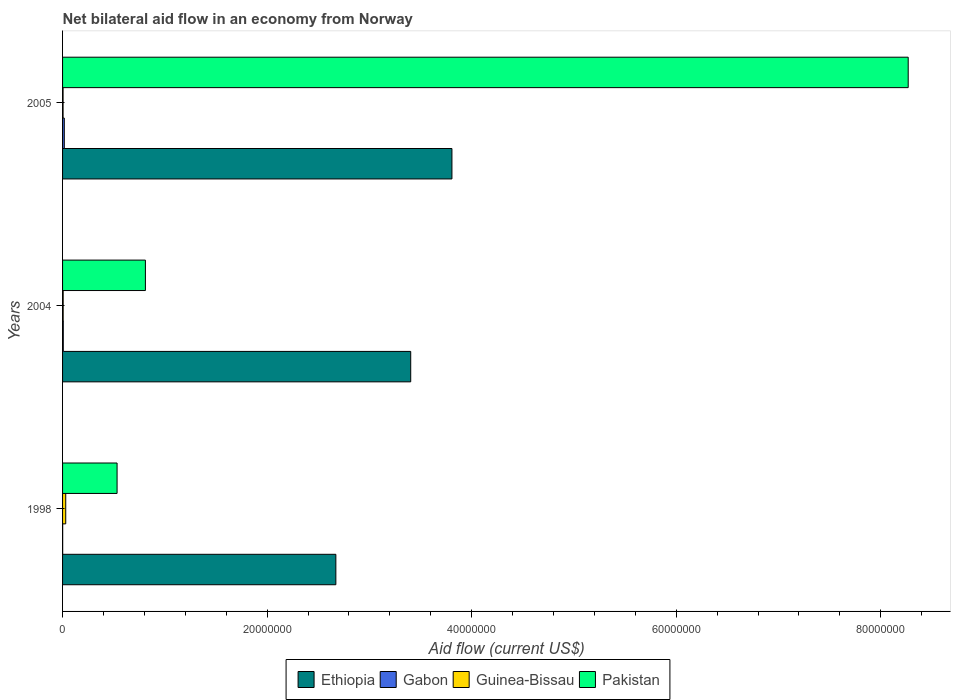How many groups of bars are there?
Make the answer very short. 3. Are the number of bars on each tick of the Y-axis equal?
Make the answer very short. Yes. How many bars are there on the 3rd tick from the bottom?
Give a very brief answer. 4. What is the net bilateral aid flow in Gabon in 2004?
Provide a succinct answer. 7.00e+04. Across all years, what is the maximum net bilateral aid flow in Guinea-Bissau?
Offer a very short reply. 3.10e+05. What is the total net bilateral aid flow in Pakistan in the graph?
Your response must be concise. 9.61e+07. What is the difference between the net bilateral aid flow in Guinea-Bissau in 1998 and that in 2004?
Your response must be concise. 2.50e+05. What is the difference between the net bilateral aid flow in Gabon in 2004 and the net bilateral aid flow in Pakistan in 1998?
Your answer should be very brief. -5.26e+06. What is the average net bilateral aid flow in Gabon per year?
Offer a terse response. 8.33e+04. In the year 2004, what is the difference between the net bilateral aid flow in Pakistan and net bilateral aid flow in Gabon?
Make the answer very short. 8.03e+06. In how many years, is the net bilateral aid flow in Pakistan greater than 52000000 US$?
Keep it short and to the point. 1. What is the ratio of the net bilateral aid flow in Gabon in 1998 to that in 2005?
Provide a succinct answer. 0.06. Is the difference between the net bilateral aid flow in Pakistan in 2004 and 2005 greater than the difference between the net bilateral aid flow in Gabon in 2004 and 2005?
Give a very brief answer. No. What is the difference between the highest and the second highest net bilateral aid flow in Ethiopia?
Provide a short and direct response. 4.03e+06. What is the difference between the highest and the lowest net bilateral aid flow in Gabon?
Keep it short and to the point. 1.60e+05. Is it the case that in every year, the sum of the net bilateral aid flow in Gabon and net bilateral aid flow in Pakistan is greater than the sum of net bilateral aid flow in Guinea-Bissau and net bilateral aid flow in Ethiopia?
Provide a succinct answer. Yes. What does the 3rd bar from the top in 2005 represents?
Ensure brevity in your answer.  Gabon. What does the 3rd bar from the bottom in 1998 represents?
Offer a very short reply. Guinea-Bissau. How many bars are there?
Offer a terse response. 12. Are all the bars in the graph horizontal?
Keep it short and to the point. Yes. How many years are there in the graph?
Your answer should be very brief. 3. What is the difference between two consecutive major ticks on the X-axis?
Your answer should be compact. 2.00e+07. Does the graph contain any zero values?
Give a very brief answer. No. Where does the legend appear in the graph?
Keep it short and to the point. Bottom center. What is the title of the graph?
Provide a succinct answer. Net bilateral aid flow in an economy from Norway. What is the label or title of the X-axis?
Offer a very short reply. Aid flow (current US$). What is the label or title of the Y-axis?
Make the answer very short. Years. What is the Aid flow (current US$) of Ethiopia in 1998?
Your answer should be very brief. 2.67e+07. What is the Aid flow (current US$) in Gabon in 1998?
Offer a terse response. 10000. What is the Aid flow (current US$) of Pakistan in 1998?
Ensure brevity in your answer.  5.33e+06. What is the Aid flow (current US$) of Ethiopia in 2004?
Provide a succinct answer. 3.40e+07. What is the Aid flow (current US$) in Pakistan in 2004?
Your answer should be very brief. 8.10e+06. What is the Aid flow (current US$) in Ethiopia in 2005?
Provide a succinct answer. 3.81e+07. What is the Aid flow (current US$) in Pakistan in 2005?
Give a very brief answer. 8.27e+07. Across all years, what is the maximum Aid flow (current US$) in Ethiopia?
Your answer should be compact. 3.81e+07. Across all years, what is the maximum Aid flow (current US$) of Gabon?
Give a very brief answer. 1.70e+05. Across all years, what is the maximum Aid flow (current US$) in Guinea-Bissau?
Provide a short and direct response. 3.10e+05. Across all years, what is the maximum Aid flow (current US$) in Pakistan?
Your answer should be compact. 8.27e+07. Across all years, what is the minimum Aid flow (current US$) of Ethiopia?
Offer a terse response. 2.67e+07. Across all years, what is the minimum Aid flow (current US$) of Gabon?
Offer a very short reply. 10000. Across all years, what is the minimum Aid flow (current US$) of Pakistan?
Provide a succinct answer. 5.33e+06. What is the total Aid flow (current US$) in Ethiopia in the graph?
Offer a terse response. 9.88e+07. What is the total Aid flow (current US$) in Gabon in the graph?
Offer a terse response. 2.50e+05. What is the total Aid flow (current US$) of Pakistan in the graph?
Your response must be concise. 9.61e+07. What is the difference between the Aid flow (current US$) of Ethiopia in 1998 and that in 2004?
Offer a terse response. -7.32e+06. What is the difference between the Aid flow (current US$) in Gabon in 1998 and that in 2004?
Offer a very short reply. -6.00e+04. What is the difference between the Aid flow (current US$) in Guinea-Bissau in 1998 and that in 2004?
Keep it short and to the point. 2.50e+05. What is the difference between the Aid flow (current US$) of Pakistan in 1998 and that in 2004?
Your answer should be compact. -2.77e+06. What is the difference between the Aid flow (current US$) in Ethiopia in 1998 and that in 2005?
Your response must be concise. -1.14e+07. What is the difference between the Aid flow (current US$) of Guinea-Bissau in 1998 and that in 2005?
Provide a short and direct response. 2.60e+05. What is the difference between the Aid flow (current US$) of Pakistan in 1998 and that in 2005?
Your answer should be compact. -7.74e+07. What is the difference between the Aid flow (current US$) in Ethiopia in 2004 and that in 2005?
Offer a very short reply. -4.03e+06. What is the difference between the Aid flow (current US$) of Pakistan in 2004 and that in 2005?
Provide a succinct answer. -7.46e+07. What is the difference between the Aid flow (current US$) of Ethiopia in 1998 and the Aid flow (current US$) of Gabon in 2004?
Ensure brevity in your answer.  2.66e+07. What is the difference between the Aid flow (current US$) in Ethiopia in 1998 and the Aid flow (current US$) in Guinea-Bissau in 2004?
Your response must be concise. 2.67e+07. What is the difference between the Aid flow (current US$) in Ethiopia in 1998 and the Aid flow (current US$) in Pakistan in 2004?
Provide a succinct answer. 1.86e+07. What is the difference between the Aid flow (current US$) of Gabon in 1998 and the Aid flow (current US$) of Guinea-Bissau in 2004?
Your response must be concise. -5.00e+04. What is the difference between the Aid flow (current US$) in Gabon in 1998 and the Aid flow (current US$) in Pakistan in 2004?
Your answer should be compact. -8.09e+06. What is the difference between the Aid flow (current US$) in Guinea-Bissau in 1998 and the Aid flow (current US$) in Pakistan in 2004?
Provide a succinct answer. -7.79e+06. What is the difference between the Aid flow (current US$) of Ethiopia in 1998 and the Aid flow (current US$) of Gabon in 2005?
Your answer should be compact. 2.66e+07. What is the difference between the Aid flow (current US$) in Ethiopia in 1998 and the Aid flow (current US$) in Guinea-Bissau in 2005?
Give a very brief answer. 2.67e+07. What is the difference between the Aid flow (current US$) of Ethiopia in 1998 and the Aid flow (current US$) of Pakistan in 2005?
Your answer should be very brief. -5.60e+07. What is the difference between the Aid flow (current US$) in Gabon in 1998 and the Aid flow (current US$) in Guinea-Bissau in 2005?
Provide a short and direct response. -4.00e+04. What is the difference between the Aid flow (current US$) in Gabon in 1998 and the Aid flow (current US$) in Pakistan in 2005?
Offer a very short reply. -8.27e+07. What is the difference between the Aid flow (current US$) in Guinea-Bissau in 1998 and the Aid flow (current US$) in Pakistan in 2005?
Keep it short and to the point. -8.24e+07. What is the difference between the Aid flow (current US$) of Ethiopia in 2004 and the Aid flow (current US$) of Gabon in 2005?
Keep it short and to the point. 3.39e+07. What is the difference between the Aid flow (current US$) of Ethiopia in 2004 and the Aid flow (current US$) of Guinea-Bissau in 2005?
Provide a succinct answer. 3.40e+07. What is the difference between the Aid flow (current US$) in Ethiopia in 2004 and the Aid flow (current US$) in Pakistan in 2005?
Your response must be concise. -4.86e+07. What is the difference between the Aid flow (current US$) of Gabon in 2004 and the Aid flow (current US$) of Guinea-Bissau in 2005?
Ensure brevity in your answer.  2.00e+04. What is the difference between the Aid flow (current US$) in Gabon in 2004 and the Aid flow (current US$) in Pakistan in 2005?
Your response must be concise. -8.26e+07. What is the difference between the Aid flow (current US$) of Guinea-Bissau in 2004 and the Aid flow (current US$) of Pakistan in 2005?
Offer a very short reply. -8.26e+07. What is the average Aid flow (current US$) of Ethiopia per year?
Provide a short and direct response. 3.29e+07. What is the average Aid flow (current US$) of Gabon per year?
Give a very brief answer. 8.33e+04. What is the average Aid flow (current US$) of Pakistan per year?
Your answer should be very brief. 3.20e+07. In the year 1998, what is the difference between the Aid flow (current US$) of Ethiopia and Aid flow (current US$) of Gabon?
Make the answer very short. 2.67e+07. In the year 1998, what is the difference between the Aid flow (current US$) in Ethiopia and Aid flow (current US$) in Guinea-Bissau?
Offer a terse response. 2.64e+07. In the year 1998, what is the difference between the Aid flow (current US$) of Ethiopia and Aid flow (current US$) of Pakistan?
Provide a short and direct response. 2.14e+07. In the year 1998, what is the difference between the Aid flow (current US$) in Gabon and Aid flow (current US$) in Guinea-Bissau?
Provide a short and direct response. -3.00e+05. In the year 1998, what is the difference between the Aid flow (current US$) of Gabon and Aid flow (current US$) of Pakistan?
Your answer should be compact. -5.32e+06. In the year 1998, what is the difference between the Aid flow (current US$) in Guinea-Bissau and Aid flow (current US$) in Pakistan?
Your answer should be compact. -5.02e+06. In the year 2004, what is the difference between the Aid flow (current US$) in Ethiopia and Aid flow (current US$) in Gabon?
Your response must be concise. 3.40e+07. In the year 2004, what is the difference between the Aid flow (current US$) in Ethiopia and Aid flow (current US$) in Guinea-Bissau?
Keep it short and to the point. 3.40e+07. In the year 2004, what is the difference between the Aid flow (current US$) in Ethiopia and Aid flow (current US$) in Pakistan?
Make the answer very short. 2.59e+07. In the year 2004, what is the difference between the Aid flow (current US$) in Gabon and Aid flow (current US$) in Guinea-Bissau?
Your response must be concise. 10000. In the year 2004, what is the difference between the Aid flow (current US$) in Gabon and Aid flow (current US$) in Pakistan?
Your answer should be compact. -8.03e+06. In the year 2004, what is the difference between the Aid flow (current US$) in Guinea-Bissau and Aid flow (current US$) in Pakistan?
Make the answer very short. -8.04e+06. In the year 2005, what is the difference between the Aid flow (current US$) in Ethiopia and Aid flow (current US$) in Gabon?
Offer a terse response. 3.79e+07. In the year 2005, what is the difference between the Aid flow (current US$) of Ethiopia and Aid flow (current US$) of Guinea-Bissau?
Provide a short and direct response. 3.80e+07. In the year 2005, what is the difference between the Aid flow (current US$) in Ethiopia and Aid flow (current US$) in Pakistan?
Make the answer very short. -4.46e+07. In the year 2005, what is the difference between the Aid flow (current US$) of Gabon and Aid flow (current US$) of Guinea-Bissau?
Provide a succinct answer. 1.20e+05. In the year 2005, what is the difference between the Aid flow (current US$) in Gabon and Aid flow (current US$) in Pakistan?
Make the answer very short. -8.25e+07. In the year 2005, what is the difference between the Aid flow (current US$) of Guinea-Bissau and Aid flow (current US$) of Pakistan?
Make the answer very short. -8.26e+07. What is the ratio of the Aid flow (current US$) of Ethiopia in 1998 to that in 2004?
Your answer should be very brief. 0.79. What is the ratio of the Aid flow (current US$) of Gabon in 1998 to that in 2004?
Give a very brief answer. 0.14. What is the ratio of the Aid flow (current US$) of Guinea-Bissau in 1998 to that in 2004?
Provide a succinct answer. 5.17. What is the ratio of the Aid flow (current US$) of Pakistan in 1998 to that in 2004?
Keep it short and to the point. 0.66. What is the ratio of the Aid flow (current US$) of Ethiopia in 1998 to that in 2005?
Provide a short and direct response. 0.7. What is the ratio of the Aid flow (current US$) in Gabon in 1998 to that in 2005?
Provide a succinct answer. 0.06. What is the ratio of the Aid flow (current US$) in Guinea-Bissau in 1998 to that in 2005?
Your response must be concise. 6.2. What is the ratio of the Aid flow (current US$) of Pakistan in 1998 to that in 2005?
Provide a short and direct response. 0.06. What is the ratio of the Aid flow (current US$) of Ethiopia in 2004 to that in 2005?
Ensure brevity in your answer.  0.89. What is the ratio of the Aid flow (current US$) in Gabon in 2004 to that in 2005?
Ensure brevity in your answer.  0.41. What is the ratio of the Aid flow (current US$) in Pakistan in 2004 to that in 2005?
Offer a very short reply. 0.1. What is the difference between the highest and the second highest Aid flow (current US$) of Ethiopia?
Your answer should be compact. 4.03e+06. What is the difference between the highest and the second highest Aid flow (current US$) in Pakistan?
Provide a short and direct response. 7.46e+07. What is the difference between the highest and the lowest Aid flow (current US$) in Ethiopia?
Provide a succinct answer. 1.14e+07. What is the difference between the highest and the lowest Aid flow (current US$) in Guinea-Bissau?
Offer a very short reply. 2.60e+05. What is the difference between the highest and the lowest Aid flow (current US$) in Pakistan?
Give a very brief answer. 7.74e+07. 